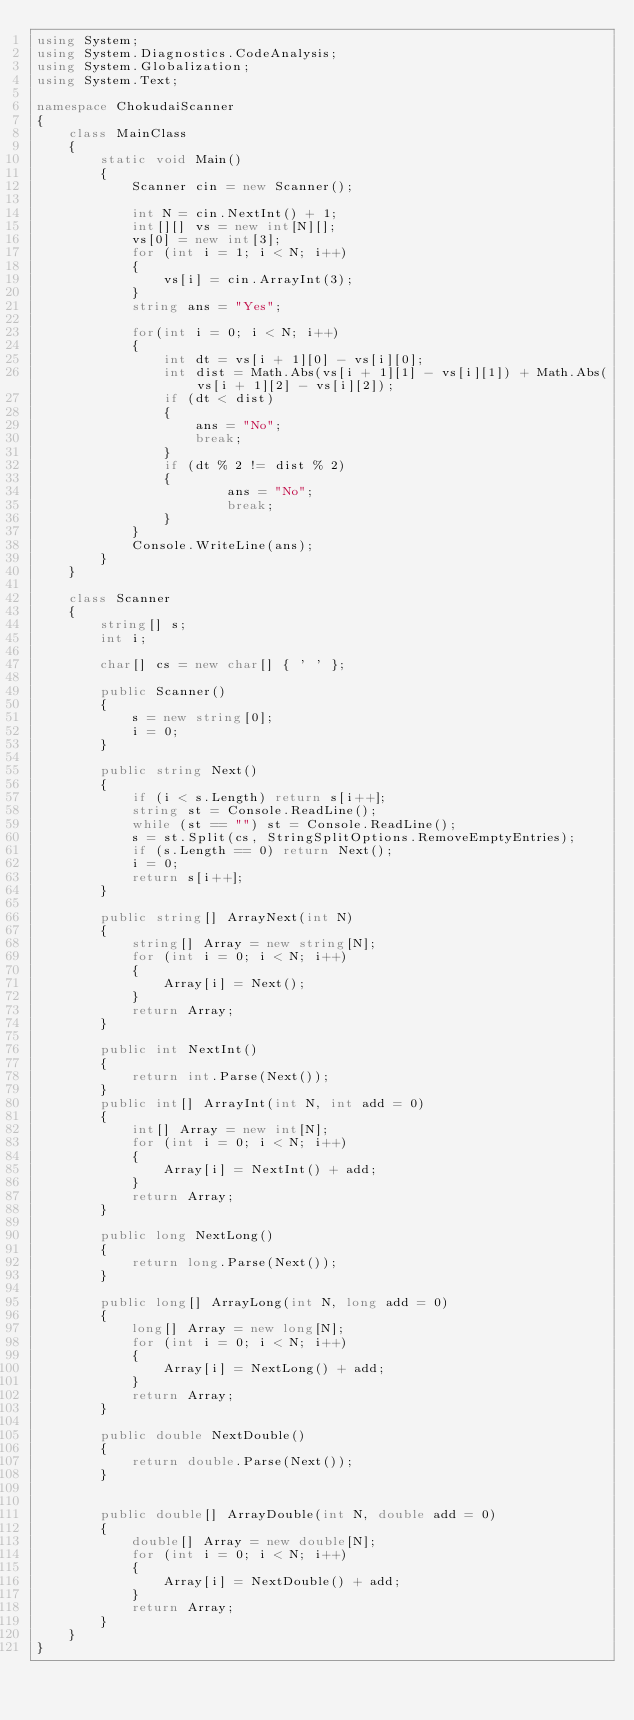Convert code to text. <code><loc_0><loc_0><loc_500><loc_500><_C#_>using System;
using System.Diagnostics.CodeAnalysis;
using System.Globalization;
using System.Text;

namespace ChokudaiScanner
{
    class MainClass
    {
        static void Main()
        {
            Scanner cin = new Scanner();

            int N = cin.NextInt() + 1;
            int[][] vs = new int[N][];
            vs[0] = new int[3];
            for (int i = 1; i < N; i++)
            {
                vs[i] = cin.ArrayInt(3);
            }
            string ans = "Yes";
            
            for(int i = 0; i < N; i++)
            { 
                int dt = vs[i + 1][0] - vs[i][0];
                int dist = Math.Abs(vs[i + 1][1] - vs[i][1]) + Math.Abs(vs[i + 1][2] - vs[i][2]);
                if (dt < dist)
                {
                    ans = "No";
                    break;
                }
                if (dt % 2 != dist % 2)
                {
                        ans = "No";
                        break;
                }
            }
            Console.WriteLine(ans);
        }
    }

    class Scanner
    {
        string[] s;
        int i;

        char[] cs = new char[] { ' ' };

        public Scanner()
        {
            s = new string[0];
            i = 0;
        }

        public string Next()
        {
            if (i < s.Length) return s[i++];
            string st = Console.ReadLine();
            while (st == "") st = Console.ReadLine();
            s = st.Split(cs, StringSplitOptions.RemoveEmptyEntries);
            if (s.Length == 0) return Next();
            i = 0;
            return s[i++];
        }

        public string[] ArrayNext(int N)
        {
            string[] Array = new string[N];
            for (int i = 0; i < N; i++)
            {
                Array[i] = Next();
            }
            return Array;
        }

        public int NextInt()
        {
            return int.Parse(Next());
        }
        public int[] ArrayInt(int N, int add = 0)
        {
            int[] Array = new int[N];
            for (int i = 0; i < N; i++)
            {
                Array[i] = NextInt() + add;
            }
            return Array;
        }

        public long NextLong()
        {
            return long.Parse(Next());
        }

        public long[] ArrayLong(int N, long add = 0)
        {
            long[] Array = new long[N];
            for (int i = 0; i < N; i++)
            {
                Array[i] = NextLong() + add;
            }
            return Array;
        }

        public double NextDouble()
        {
            return double.Parse(Next());
        }


        public double[] ArrayDouble(int N, double add = 0)
        {
            double[] Array = new double[N];
            for (int i = 0; i < N; i++)
            {
                Array[i] = NextDouble() + add;
            }
            return Array;
        }
    }
}

</code> 